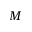<formula> <loc_0><loc_0><loc_500><loc_500>M</formula> 